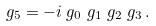<formula> <loc_0><loc_0><loc_500><loc_500>\ g _ { 5 } & = - i \ g _ { 0 } \ g _ { 1 } \ g _ { 2 } \ g _ { 3 } \, .</formula> 